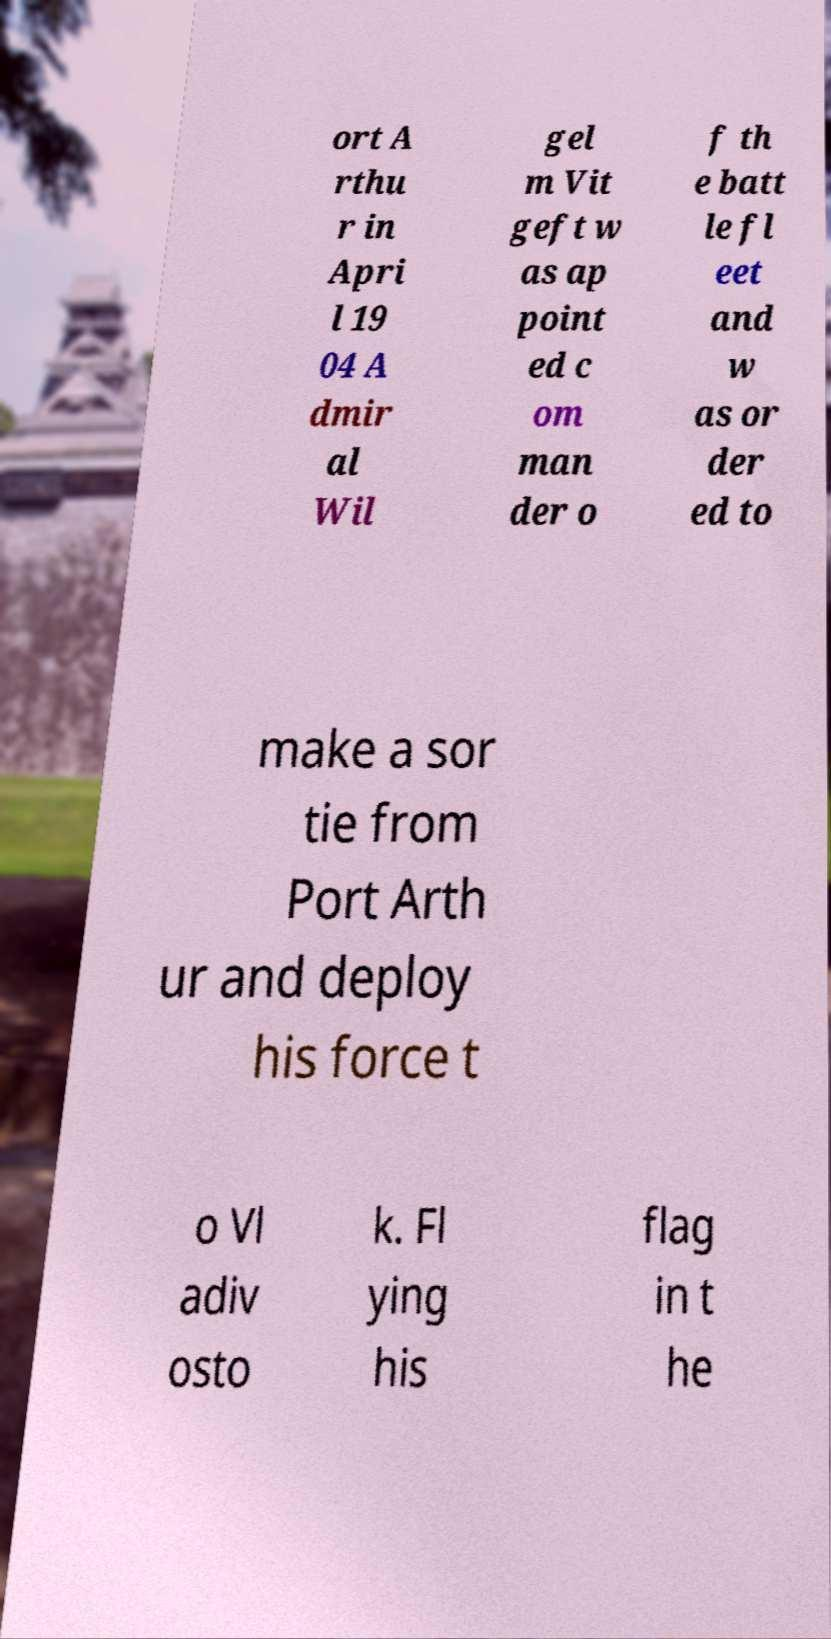Could you extract and type out the text from this image? ort A rthu r in Apri l 19 04 A dmir al Wil gel m Vit geft w as ap point ed c om man der o f th e batt le fl eet and w as or der ed to make a sor tie from Port Arth ur and deploy his force t o Vl adiv osto k. Fl ying his flag in t he 